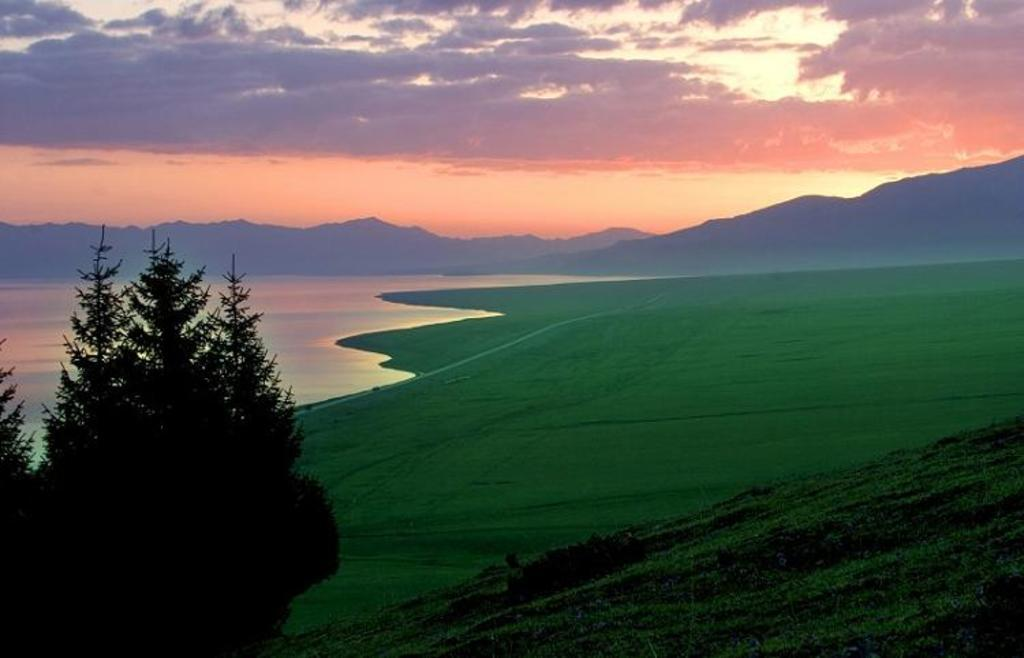What is the main feature of the image? There is water in the image. How would you describe the weather based on the sky? The sky is cloudy in the image. What type of vegetation can be seen in the image? There is a tree and grass present in the image. What type of landscape is visible in the image? There are hills visible in the image. Can you describe the lighting in the image? Sunlight is observable in the image. What is the title of the book that is being read by the mountain in the image? There is no mountain or book present in the image. 